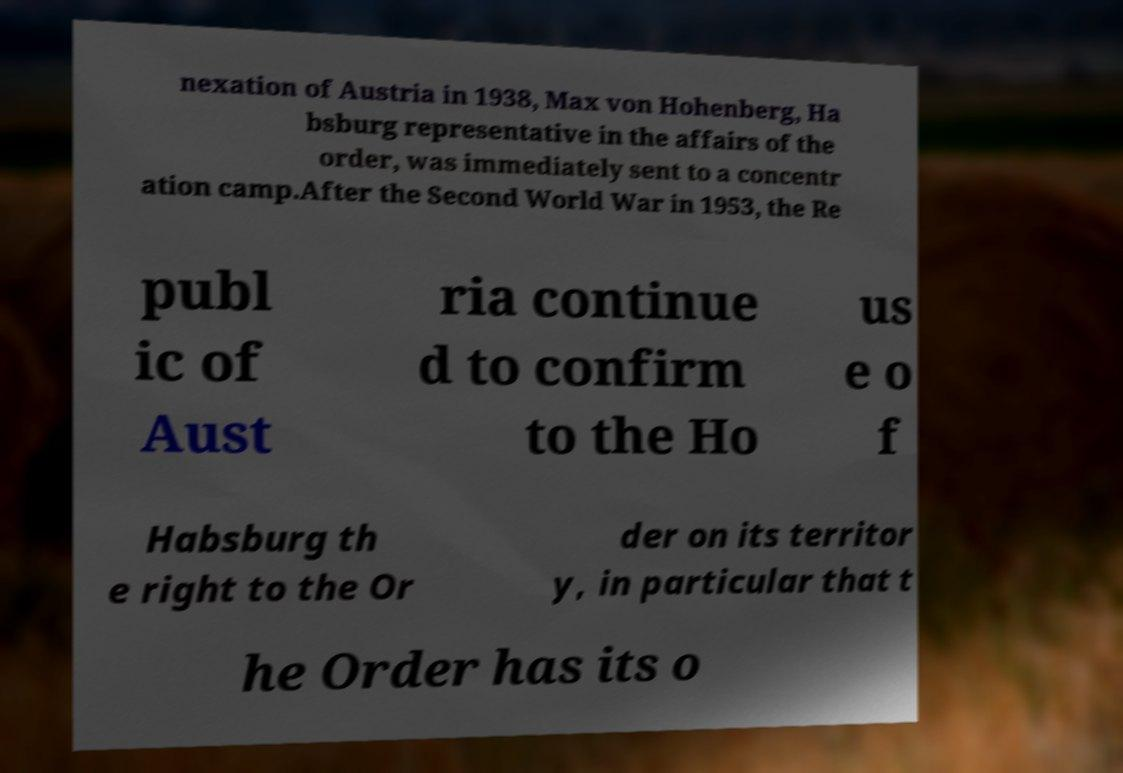There's text embedded in this image that I need extracted. Can you transcribe it verbatim? nexation of Austria in 1938, Max von Hohenberg, Ha bsburg representative in the affairs of the order, was immediately sent to a concentr ation camp.After the Second World War in 1953, the Re publ ic of Aust ria continue d to confirm to the Ho us e o f Habsburg th e right to the Or der on its territor y, in particular that t he Order has its o 